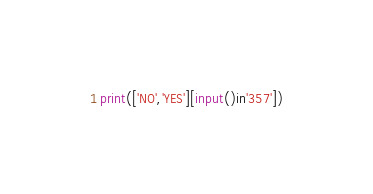Convert code to text. <code><loc_0><loc_0><loc_500><loc_500><_Python_>print(['NO','YES'][input()in'357'])</code> 